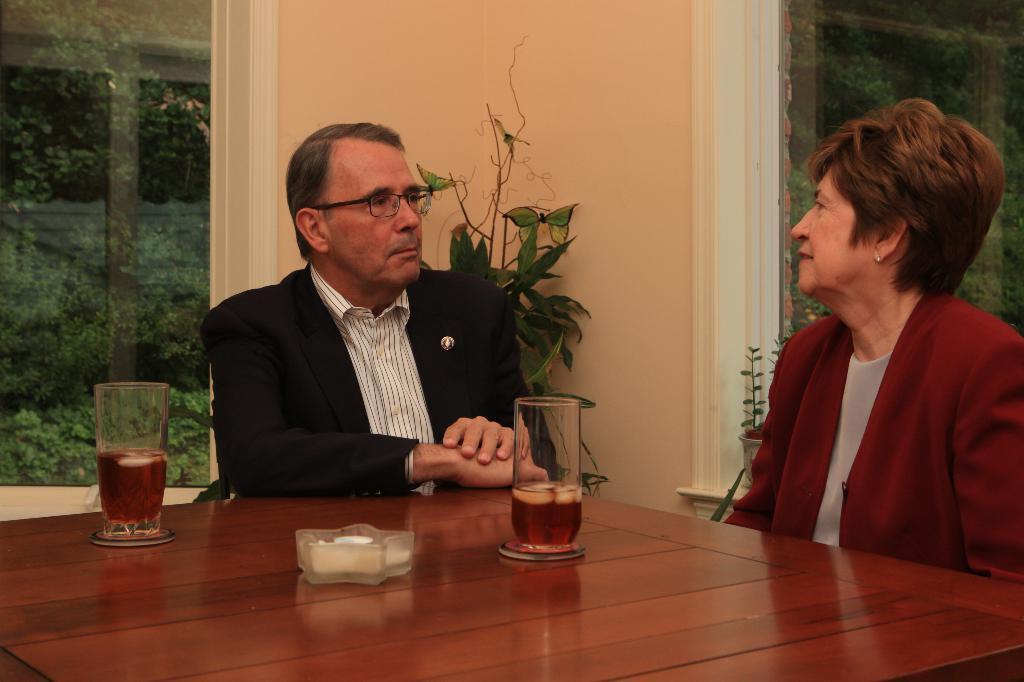How would you summarize this image in a sentence or two? In this picture there are two persons one man and one woman sitting on the chair and they have a table in front of them with two wine glasses on it. 